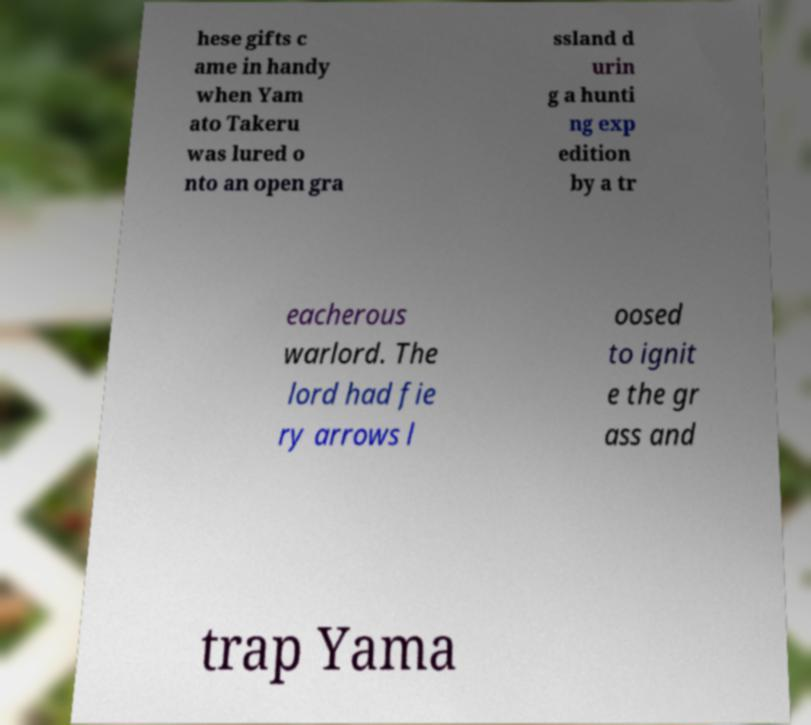Please read and relay the text visible in this image. What does it say? hese gifts c ame in handy when Yam ato Takeru was lured o nto an open gra ssland d urin g a hunti ng exp edition by a tr eacherous warlord. The lord had fie ry arrows l oosed to ignit e the gr ass and trap Yama 